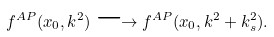Convert formula to latex. <formula><loc_0><loc_0><loc_500><loc_500>f ^ { A P } ( x _ { 0 } , k ^ { 2 } ) \longrightarrow f ^ { A P } ( x _ { 0 } , k ^ { 2 } + k _ { s } ^ { 2 } ) .</formula> 